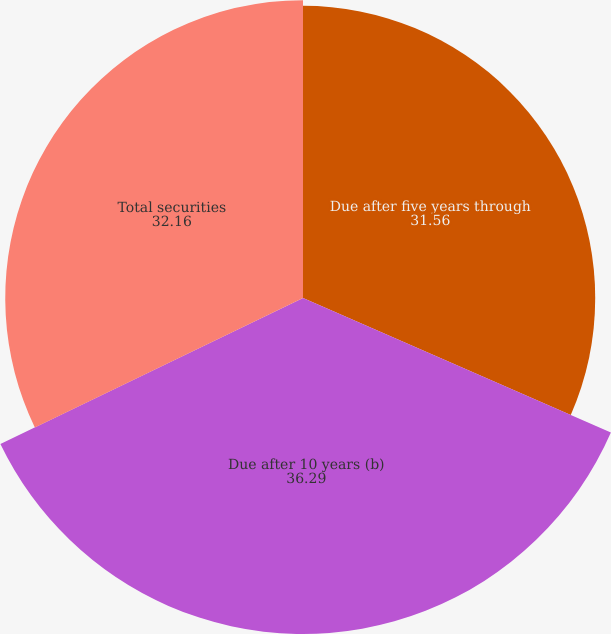<chart> <loc_0><loc_0><loc_500><loc_500><pie_chart><fcel>Due after five years through<fcel>Due after 10 years (b)<fcel>Total securities<nl><fcel>31.56%<fcel>36.29%<fcel>32.16%<nl></chart> 